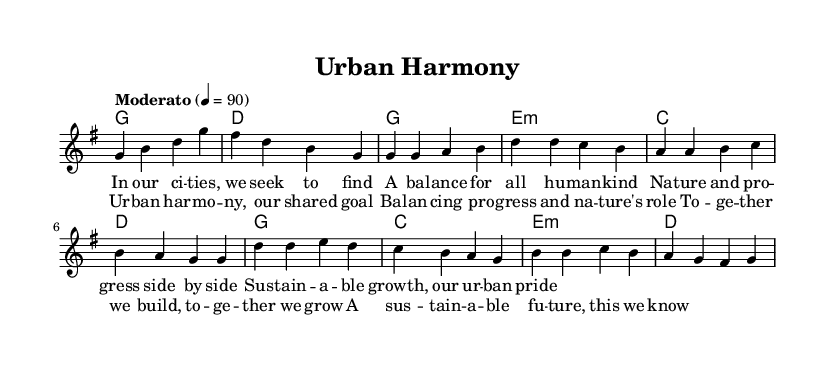What is the key signature of this music? The key signature is G major, indicated by the presence of one sharp (F#). The presence of this sharp and the context of typical hymn music help identify the key.
Answer: G major What is the time signature of this music? The time signature is 4/4, as indicated at the beginning of the score. This means there are four beats in each measure, and a quarter note receives one beat.
Answer: 4/4 What is the tempo marking of this music? The tempo marking is "Moderato," which suggests a moderate speed. The score indicates a specific metronome marking of 90 beats per minute, which further clarifies the desired pace.
Answer: Moderato How many measures are in the verse? The verse contains 8 measures, as noted by counting the distinct sections of the melody and harmony parts labeled in the score, beginning with the intro and then the verse structure.
Answer: 8 What is the last note of the chorus? The last note of the chorus is G, confirmed by looking at the terminal note in the melody section of the score where the lyrics of the chorus conclude.
Answer: G What is the main theme of the lyrics? The main theme of the lyrics reflects the concept of balancing nature and urban development, which is supported by the text and context of the music as a religious piece promoting environmental harmony.
Answer: Balance between nature and progress How is the structure of this piece organized? The structure consists of an intro, followed by a verse and a chorus, creating a standard format for many religious and interfaith songs aimed at conveying a shared message. This is inferred from the layout of sections as seen in both the melody and lyrics.
Answer: Intro, Verse, Chorus 